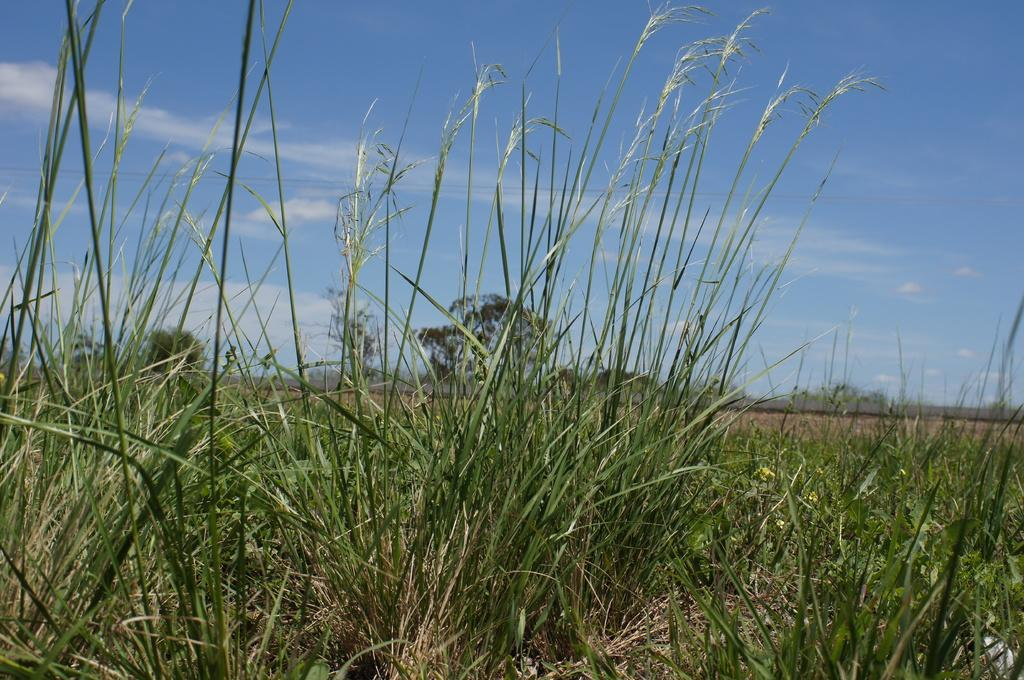What type of vegetation is visible in the image? There is grass in the image. What can be seen in the background of the image? There are trees in the background of the image. How would you describe the sky in the image? The sky is blue with clouds. What type of engine can be seen powering a vehicle in the image? There is no vehicle or engine present in the image; it features grass, trees, and a blue sky with clouds. What type of lunch is being served in the image? There is no lunch or food present in the image; it features grass, trees, and a blue sky with clouds. 